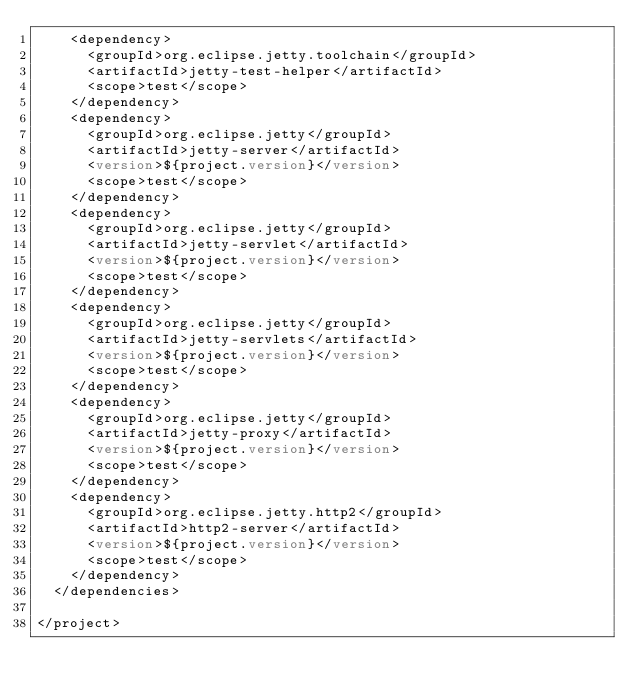<code> <loc_0><loc_0><loc_500><loc_500><_XML_>    <dependency>
      <groupId>org.eclipse.jetty.toolchain</groupId>
      <artifactId>jetty-test-helper</artifactId>
      <scope>test</scope>
    </dependency>
    <dependency>
      <groupId>org.eclipse.jetty</groupId>
      <artifactId>jetty-server</artifactId>
      <version>${project.version}</version>
      <scope>test</scope>
    </dependency>
    <dependency>
      <groupId>org.eclipse.jetty</groupId>
      <artifactId>jetty-servlet</artifactId>
      <version>${project.version}</version>
      <scope>test</scope>
    </dependency>
    <dependency>
      <groupId>org.eclipse.jetty</groupId>
      <artifactId>jetty-servlets</artifactId>
      <version>${project.version}</version>
      <scope>test</scope>
    </dependency>
    <dependency>
      <groupId>org.eclipse.jetty</groupId>
      <artifactId>jetty-proxy</artifactId>
      <version>${project.version}</version>
      <scope>test</scope>
    </dependency>
    <dependency>
      <groupId>org.eclipse.jetty.http2</groupId>
      <artifactId>http2-server</artifactId>
      <version>${project.version}</version>
      <scope>test</scope>
    </dependency>
  </dependencies>

</project>
</code> 